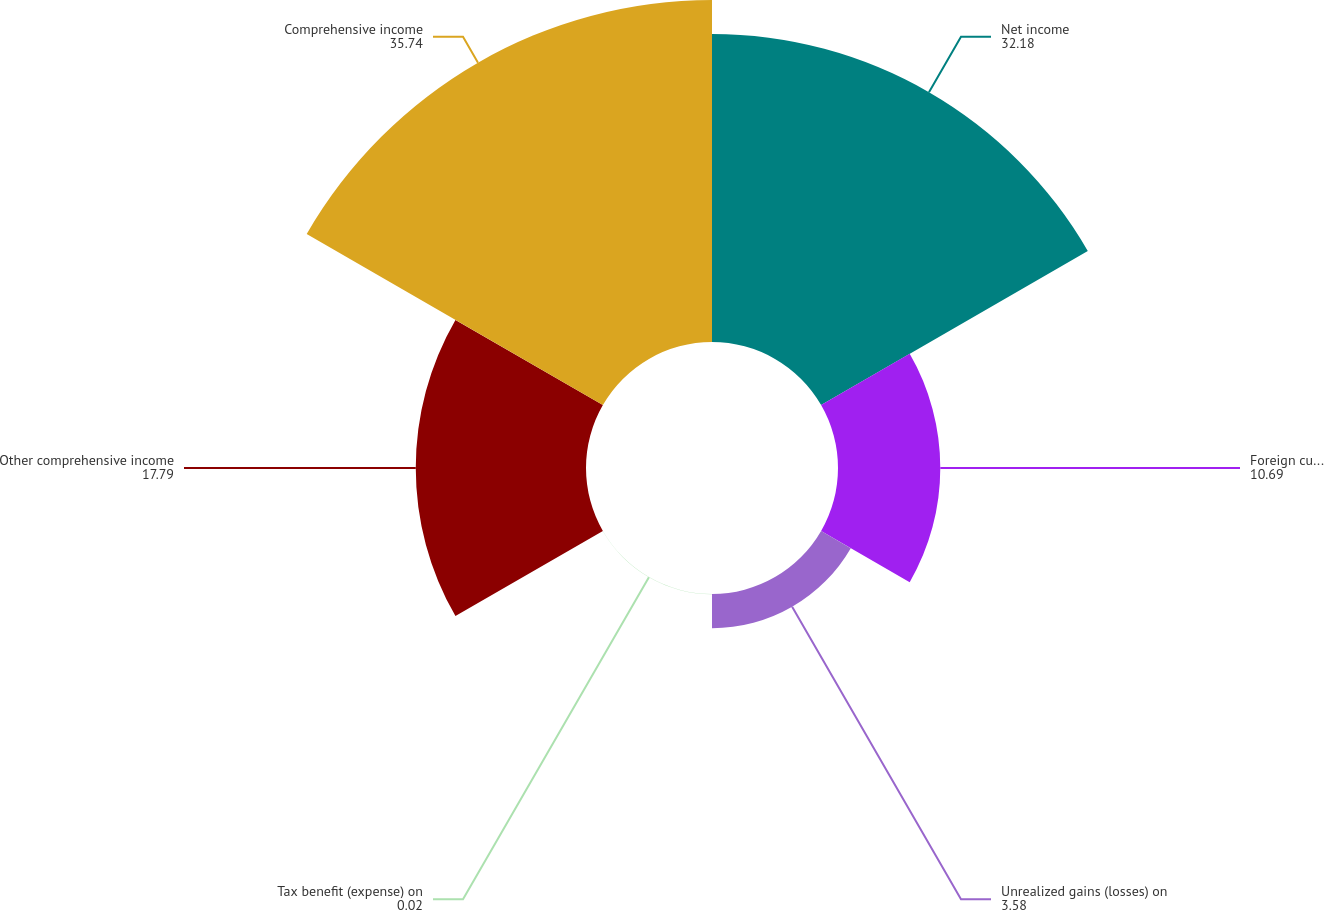Convert chart to OTSL. <chart><loc_0><loc_0><loc_500><loc_500><pie_chart><fcel>Net income<fcel>Foreign currency translation<fcel>Unrealized gains (losses) on<fcel>Tax benefit (expense) on<fcel>Other comprehensive income<fcel>Comprehensive income<nl><fcel>32.18%<fcel>10.69%<fcel>3.58%<fcel>0.02%<fcel>17.79%<fcel>35.74%<nl></chart> 